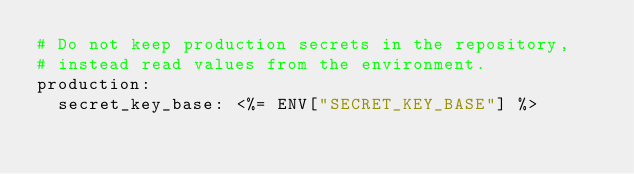Convert code to text. <code><loc_0><loc_0><loc_500><loc_500><_YAML_># Do not keep production secrets in the repository,
# instead read values from the environment.
production:
  secret_key_base: <%= ENV["SECRET_KEY_BASE"] %>
</code> 